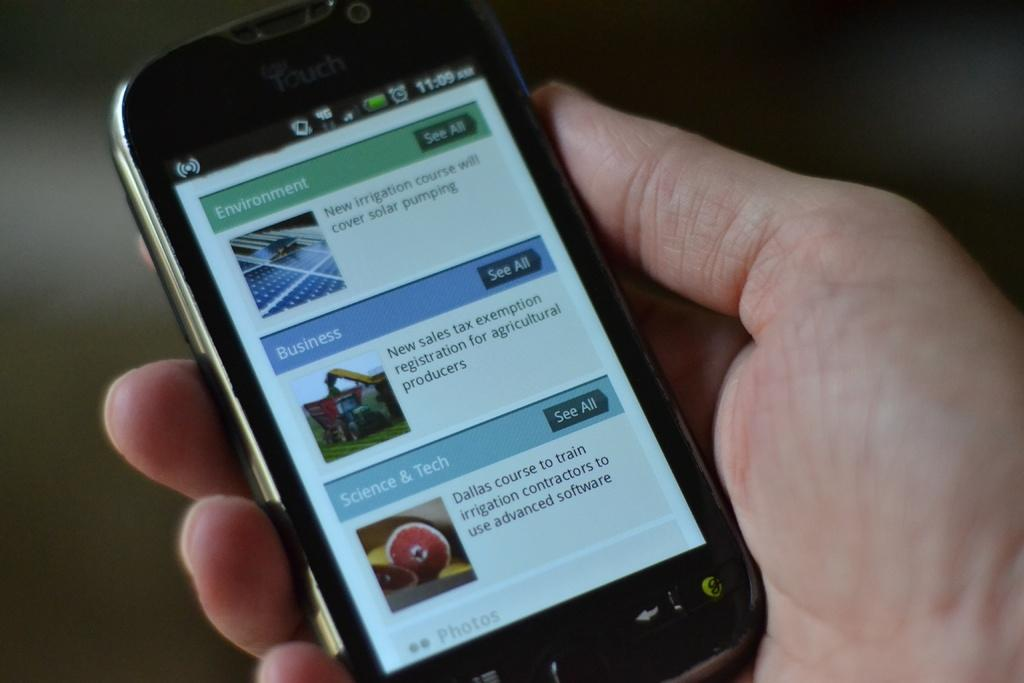<image>
Render a clear and concise summary of the photo. A cell phone displays a page with headings of Environment and Business. 